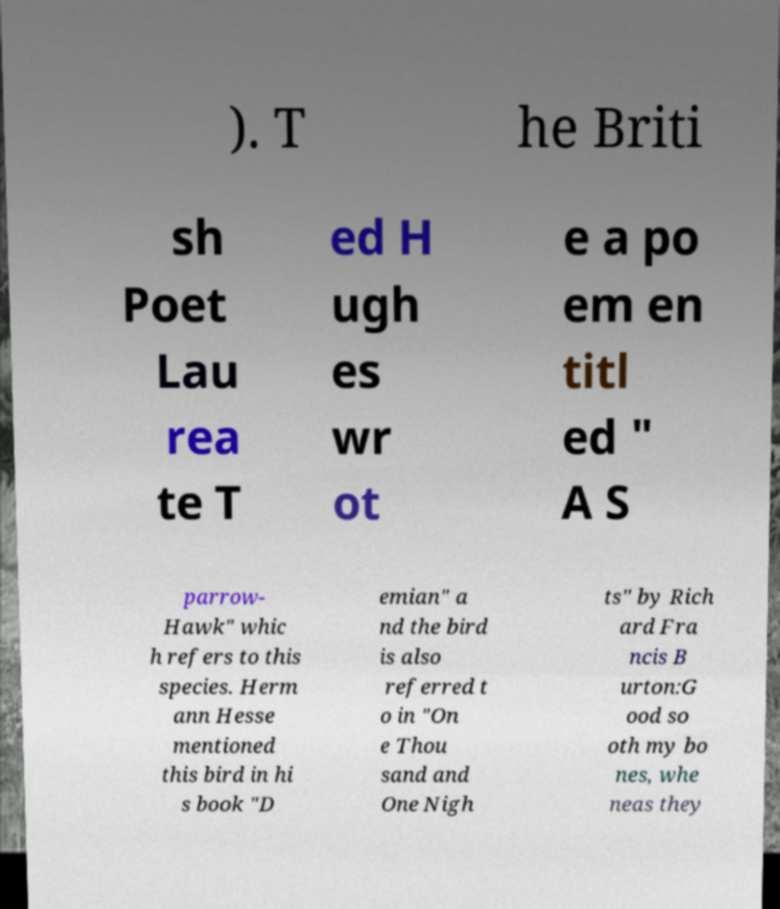Please identify and transcribe the text found in this image. ). T he Briti sh Poet Lau rea te T ed H ugh es wr ot e a po em en titl ed " A S parrow- Hawk" whic h refers to this species. Herm ann Hesse mentioned this bird in hi s book "D emian" a nd the bird is also referred t o in "On e Thou sand and One Nigh ts" by Rich ard Fra ncis B urton:G ood so oth my bo nes, whe neas they 